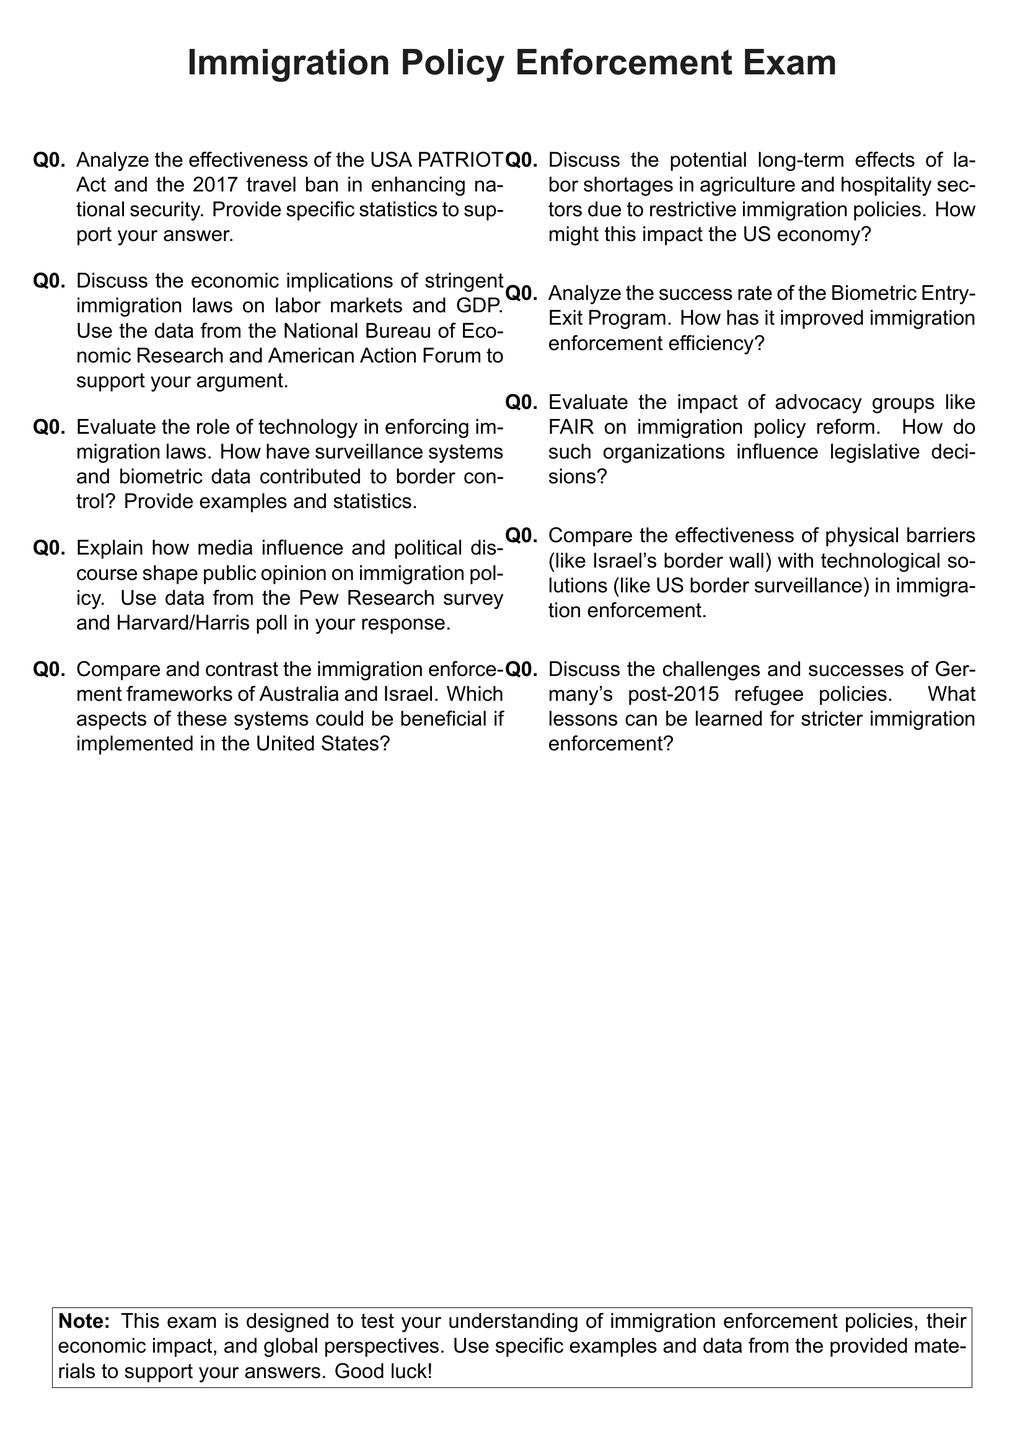What is the title of the exam? The title of the exam is stated at the beginning of the document.
Answer: Immigration Policy Enforcement Exam How many questions are in the exam? The document includes a numbered list of questions in an enumeration format.
Answer: Ten Which act is analyzed for its effectiveness regarding national security? The document mentions specific acts in the context of national security enhancement.
Answer: USA PATRIOT Act What organization is referenced for economic data related to immigration laws? The document refers to specific organizations that provide economic analysis.
Answer: National Bureau of Economic Research What country is compared alongside Israel in the immigration enforcement framework? The document includes comparisons between different countries regarding their immigration enforcement practices.
Answer: Australia What is the focus of the second question? The document lists the subjects of each question clearly, indicating the central theme of the question.
Answer: Economic implications Which advocacy group is mentioned in the context of immigration policy reform? Specific advocacy organizations are referenced concerning their influence on policy decisions.
Answer: FAIR What type of technology is evaluated in the third question? The document highlights the technological aspects related to immigration enforcement.
Answer: Surveillance systems What aspect of labor markets is discussed in relation to restrictive immigration policies? The document looks into specific economic sectors affected by immigration laws.
Answer: Labor shortages What major event is considered for Germany's immigration policies? The document references specific policies implemented in response to historical events.
Answer: 2015 refugee policies 